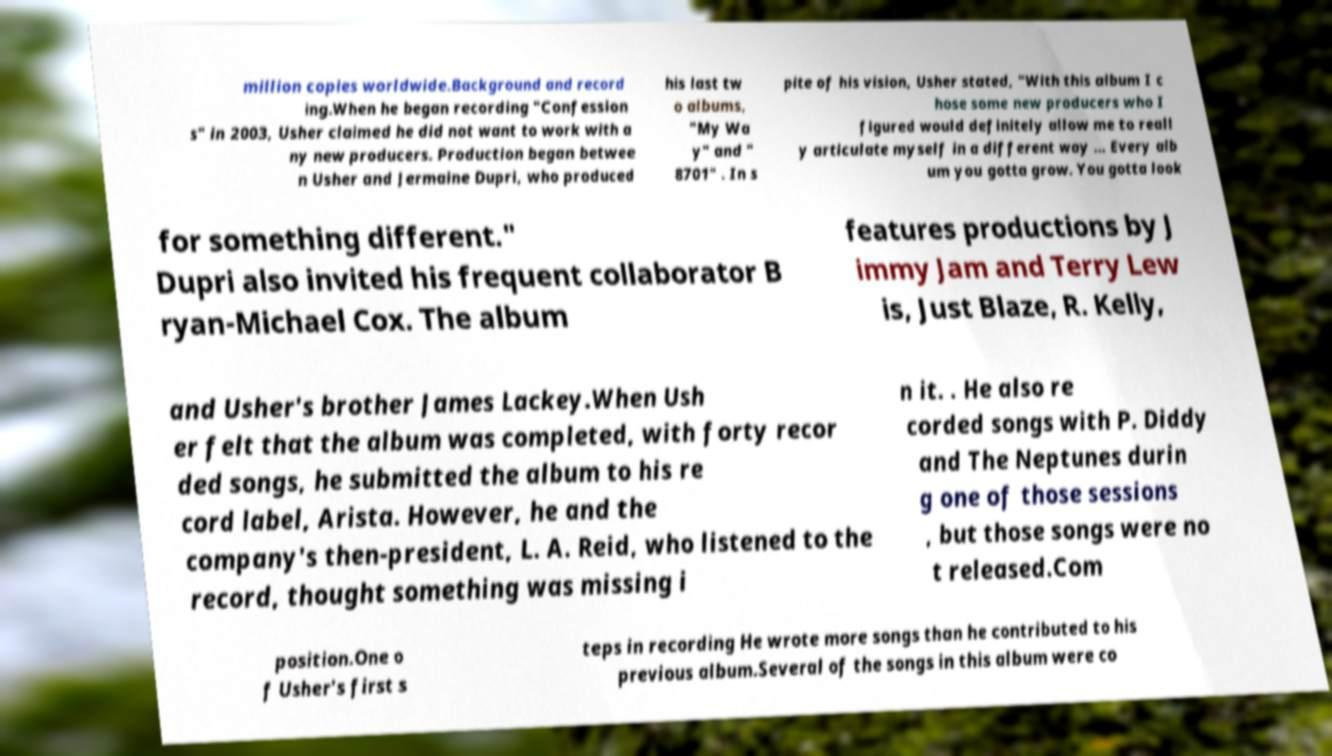Could you extract and type out the text from this image? million copies worldwide.Background and record ing.When he began recording "Confession s" in 2003, Usher claimed he did not want to work with a ny new producers. Production began betwee n Usher and Jermaine Dupri, who produced his last tw o albums, "My Wa y" and " 8701" . In s pite of his vision, Usher stated, "With this album I c hose some new producers who I figured would definitely allow me to reall y articulate myself in a different way ... Every alb um you gotta grow. You gotta look for something different." Dupri also invited his frequent collaborator B ryan-Michael Cox. The album features productions by J immy Jam and Terry Lew is, Just Blaze, R. Kelly, and Usher's brother James Lackey.When Ush er felt that the album was completed, with forty recor ded songs, he submitted the album to his re cord label, Arista. However, he and the company's then-president, L. A. Reid, who listened to the record, thought something was missing i n it. . He also re corded songs with P. Diddy and The Neptunes durin g one of those sessions , but those songs were no t released.Com position.One o f Usher's first s teps in recording He wrote more songs than he contributed to his previous album.Several of the songs in this album were co 